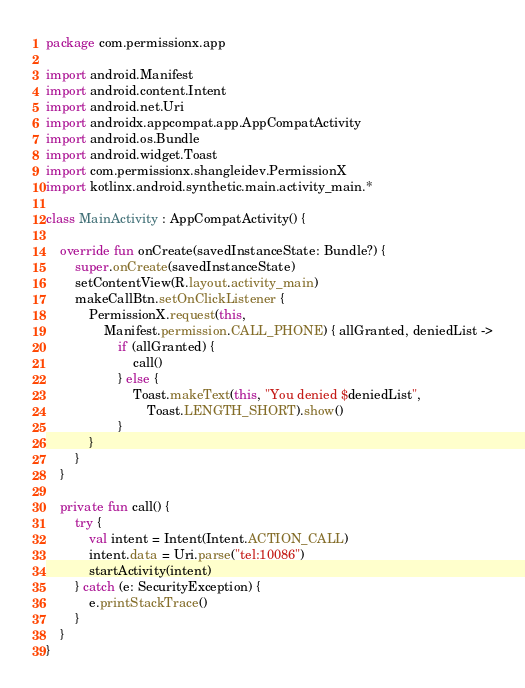<code> <loc_0><loc_0><loc_500><loc_500><_Kotlin_>package com.permissionx.app

import android.Manifest
import android.content.Intent
import android.net.Uri
import androidx.appcompat.app.AppCompatActivity
import android.os.Bundle
import android.widget.Toast
import com.permissionx.shangleidev.PermissionX
import kotlinx.android.synthetic.main.activity_main.*

class MainActivity : AppCompatActivity() {

    override fun onCreate(savedInstanceState: Bundle?) {
        super.onCreate(savedInstanceState)
        setContentView(R.layout.activity_main)
        makeCallBtn.setOnClickListener {
            PermissionX.request(this,
                Manifest.permission.CALL_PHONE) { allGranted, deniedList ->
                    if (allGranted) {
                        call()
                    } else {
                        Toast.makeText(this, "You denied $deniedList",
                            Toast.LENGTH_SHORT).show()
                    }
            }
        }
    }

    private fun call() {
        try {
            val intent = Intent(Intent.ACTION_CALL)
            intent.data = Uri.parse("tel:10086")
            startActivity(intent)
        } catch (e: SecurityException) {
            e.printStackTrace()
        }
    }
}
</code> 